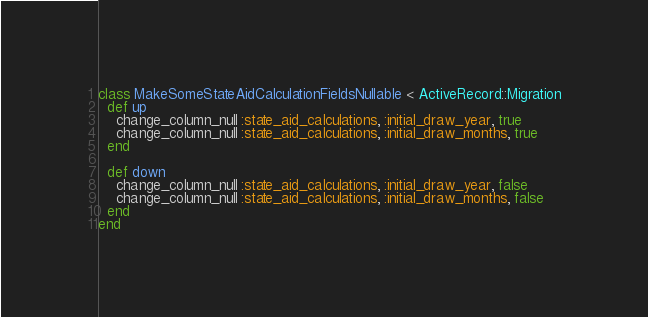<code> <loc_0><loc_0><loc_500><loc_500><_Ruby_>class MakeSomeStateAidCalculationFieldsNullable < ActiveRecord::Migration
  def up
    change_column_null :state_aid_calculations, :initial_draw_year, true
    change_column_null :state_aid_calculations, :initial_draw_months, true
  end

  def down
    change_column_null :state_aid_calculations, :initial_draw_year, false
    change_column_null :state_aid_calculations, :initial_draw_months, false
  end
end
</code> 